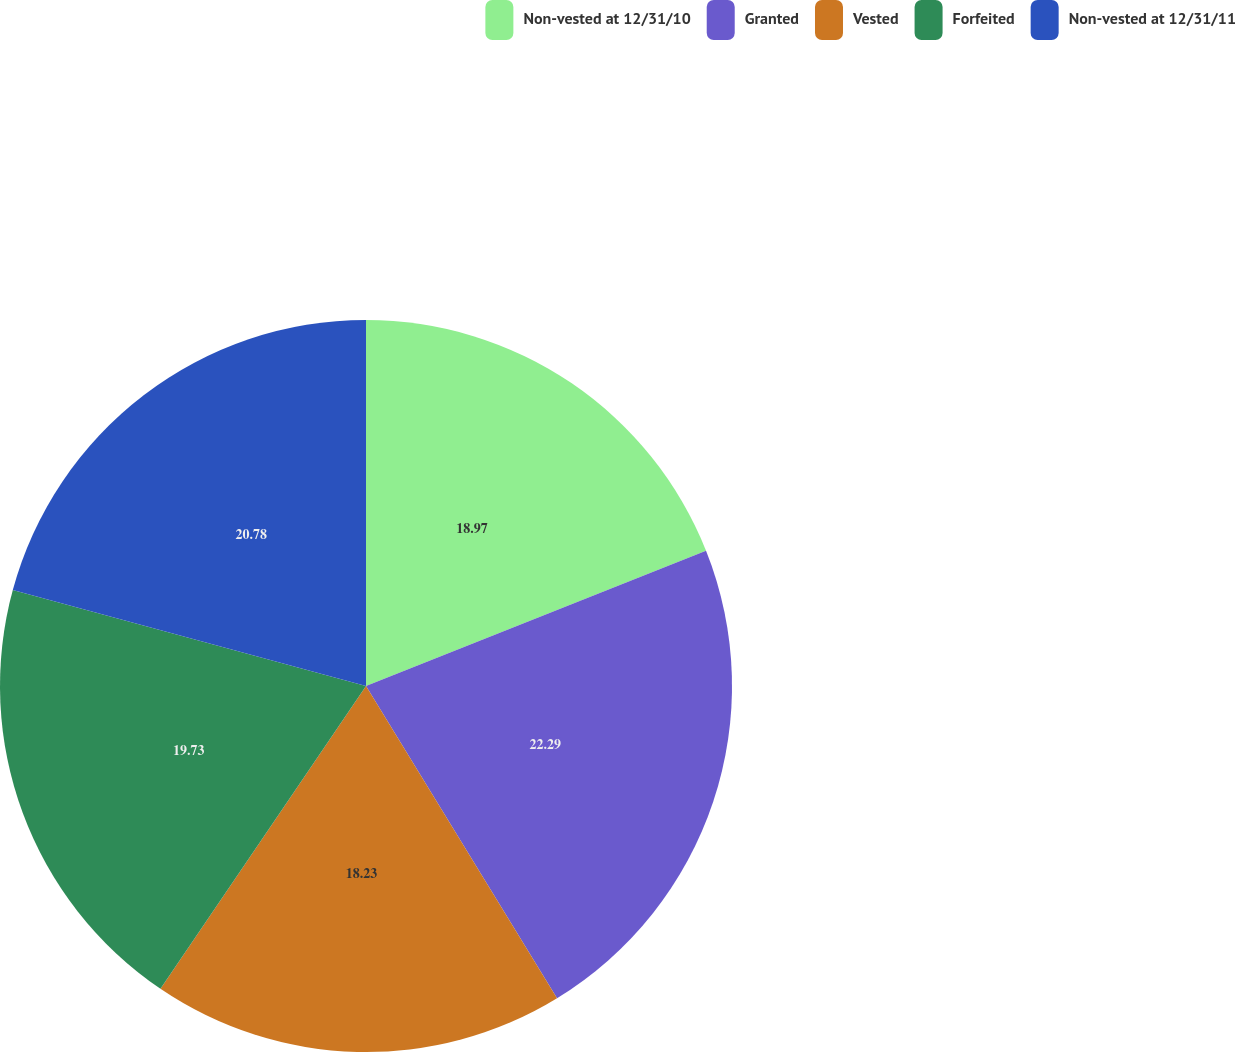<chart> <loc_0><loc_0><loc_500><loc_500><pie_chart><fcel>Non-vested at 12/31/10<fcel>Granted<fcel>Vested<fcel>Forfeited<fcel>Non-vested at 12/31/11<nl><fcel>18.97%<fcel>22.29%<fcel>18.23%<fcel>19.73%<fcel>20.78%<nl></chart> 